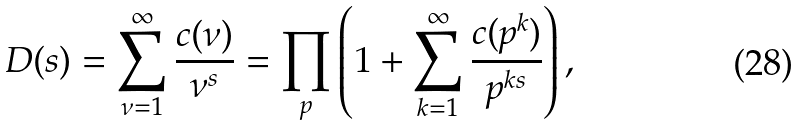<formula> <loc_0><loc_0><loc_500><loc_500>D ( s ) = \sum _ { \nu = 1 } ^ { \infty } \frac { c ( \nu ) } { \nu ^ { s } } = \prod _ { p } \left ( 1 + \sum _ { k = 1 } ^ { \infty } \frac { c ( p ^ { k } ) } { p ^ { k s } } \right ) ,</formula> 